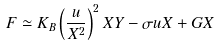<formula> <loc_0><loc_0><loc_500><loc_500>F \simeq K _ { B } \left ( \frac { u } { X ^ { 2 } } \right ) ^ { 2 } X Y - \sigma u X + G X</formula> 